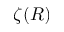Convert formula to latex. <formula><loc_0><loc_0><loc_500><loc_500>\zeta ( R )</formula> 